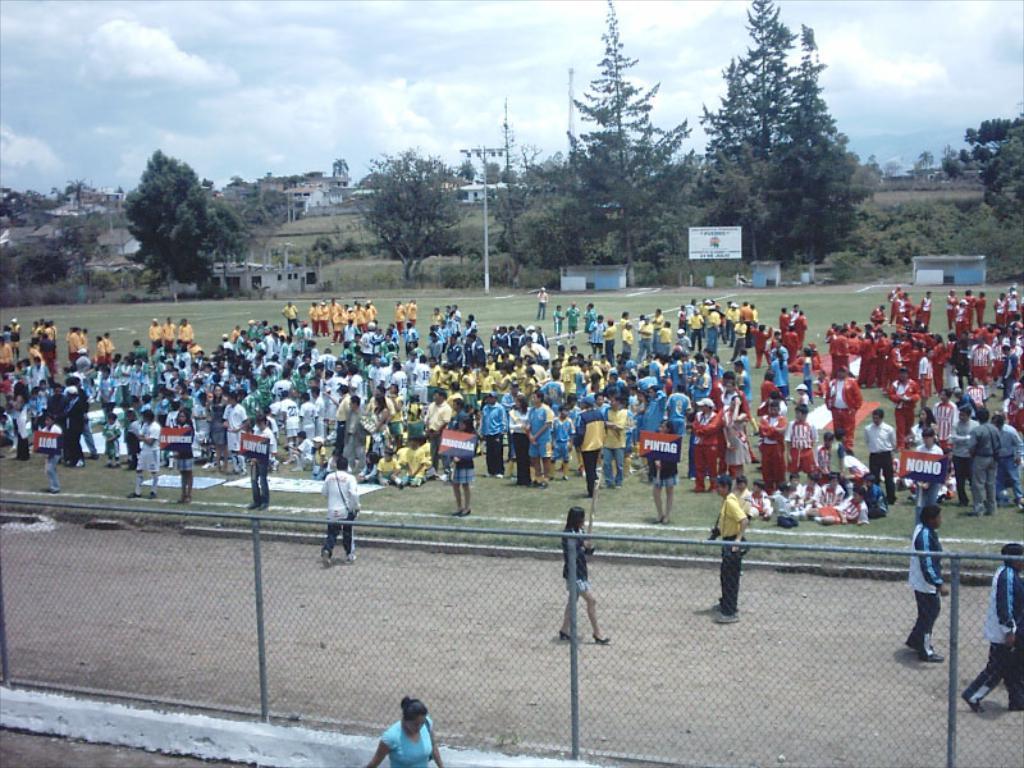Please provide a concise description of this image. At the top of the image we can see sky with clouds, trees, plants, advertisement, buildings, grass, poles and lights. In the middle of the image we can a crowd, some people holding placards in their hands, some people sitting down on the ground. At the bottom of the image we can see some walking on the ground and an iron grill. 